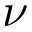Convert formula to latex. <formula><loc_0><loc_0><loc_500><loc_500>\nu</formula> 